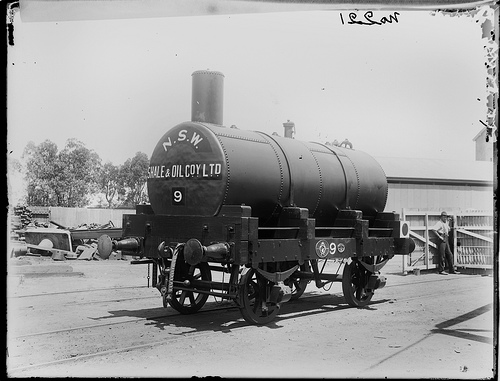Identify and read out the text in this image. N S W SHALE OIL COY 9 9 & LTD 